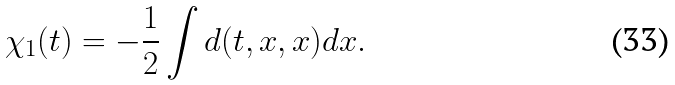Convert formula to latex. <formula><loc_0><loc_0><loc_500><loc_500>\chi _ { 1 } ( t ) = - \frac { 1 } { 2 } \int d ( t , x , x ) d x .</formula> 